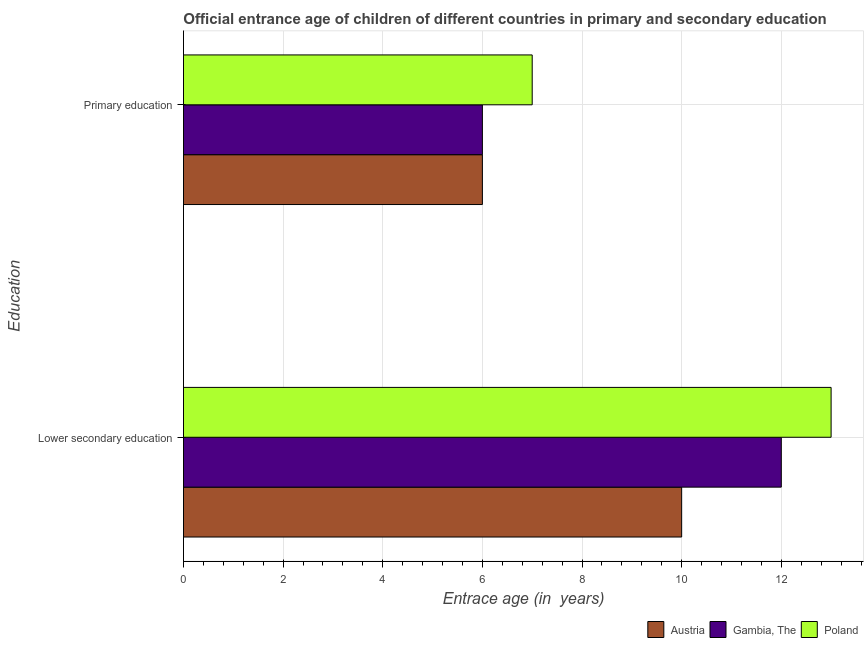How many different coloured bars are there?
Make the answer very short. 3. Are the number of bars per tick equal to the number of legend labels?
Give a very brief answer. Yes. How many bars are there on the 1st tick from the top?
Offer a very short reply. 3. What is the label of the 2nd group of bars from the top?
Your response must be concise. Lower secondary education. What is the entrance age of children in lower secondary education in Poland?
Your response must be concise. 13. Across all countries, what is the maximum entrance age of children in lower secondary education?
Provide a succinct answer. 13. Across all countries, what is the minimum entrance age of children in lower secondary education?
Offer a terse response. 10. In which country was the entrance age of children in lower secondary education maximum?
Give a very brief answer. Poland. In which country was the entrance age of children in lower secondary education minimum?
Keep it short and to the point. Austria. What is the total entrance age of chiildren in primary education in the graph?
Offer a terse response. 19. What is the difference between the entrance age of children in lower secondary education in Gambia, The and that in Austria?
Your answer should be very brief. 2. What is the difference between the entrance age of chiildren in primary education in Gambia, The and the entrance age of children in lower secondary education in Austria?
Ensure brevity in your answer.  -4. What is the average entrance age of chiildren in primary education per country?
Your answer should be very brief. 6.33. What is the difference between the entrance age of chiildren in primary education and entrance age of children in lower secondary education in Austria?
Your answer should be very brief. -4. What is the ratio of the entrance age of chiildren in primary education in Poland to that in Austria?
Give a very brief answer. 1.17. What does the 3rd bar from the top in Lower secondary education represents?
Offer a very short reply. Austria. What does the 3rd bar from the bottom in Lower secondary education represents?
Give a very brief answer. Poland. Are the values on the major ticks of X-axis written in scientific E-notation?
Give a very brief answer. No. Does the graph contain any zero values?
Your answer should be compact. No. Does the graph contain grids?
Offer a very short reply. Yes. Where does the legend appear in the graph?
Your answer should be compact. Bottom right. What is the title of the graph?
Your answer should be compact. Official entrance age of children of different countries in primary and secondary education. Does "North America" appear as one of the legend labels in the graph?
Provide a short and direct response. No. What is the label or title of the X-axis?
Keep it short and to the point. Entrace age (in  years). What is the label or title of the Y-axis?
Keep it short and to the point. Education. What is the Entrace age (in  years) in Austria in Lower secondary education?
Make the answer very short. 10. What is the Entrace age (in  years) of Poland in Lower secondary education?
Provide a short and direct response. 13. What is the Entrace age (in  years) of Poland in Primary education?
Give a very brief answer. 7. Across all Education, what is the maximum Entrace age (in  years) in Austria?
Your answer should be compact. 10. Across all Education, what is the maximum Entrace age (in  years) in Gambia, The?
Your response must be concise. 12. Across all Education, what is the maximum Entrace age (in  years) in Poland?
Your answer should be very brief. 13. Across all Education, what is the minimum Entrace age (in  years) in Austria?
Make the answer very short. 6. Across all Education, what is the minimum Entrace age (in  years) of Poland?
Your answer should be compact. 7. What is the difference between the Entrace age (in  years) in Austria in Lower secondary education and the Entrace age (in  years) in Gambia, The in Primary education?
Make the answer very short. 4. What is the difference between the Entrace age (in  years) in Austria in Lower secondary education and the Entrace age (in  years) in Poland in Primary education?
Provide a succinct answer. 3. What is the difference between the Entrace age (in  years) in Gambia, The in Lower secondary education and the Entrace age (in  years) in Poland in Primary education?
Provide a succinct answer. 5. What is the average Entrace age (in  years) in Poland per Education?
Your answer should be very brief. 10. What is the difference between the Entrace age (in  years) of Austria and Entrace age (in  years) of Gambia, The in Lower secondary education?
Provide a succinct answer. -2. What is the difference between the Entrace age (in  years) in Gambia, The and Entrace age (in  years) in Poland in Lower secondary education?
Provide a succinct answer. -1. What is the difference between the Entrace age (in  years) of Austria and Entrace age (in  years) of Gambia, The in Primary education?
Your answer should be compact. 0. What is the difference between the Entrace age (in  years) in Gambia, The and Entrace age (in  years) in Poland in Primary education?
Give a very brief answer. -1. What is the ratio of the Entrace age (in  years) in Austria in Lower secondary education to that in Primary education?
Make the answer very short. 1.67. What is the ratio of the Entrace age (in  years) in Poland in Lower secondary education to that in Primary education?
Ensure brevity in your answer.  1.86. What is the difference between the highest and the second highest Entrace age (in  years) of Austria?
Ensure brevity in your answer.  4. What is the difference between the highest and the lowest Entrace age (in  years) in Austria?
Provide a short and direct response. 4. What is the difference between the highest and the lowest Entrace age (in  years) of Gambia, The?
Provide a short and direct response. 6. What is the difference between the highest and the lowest Entrace age (in  years) of Poland?
Provide a succinct answer. 6. 